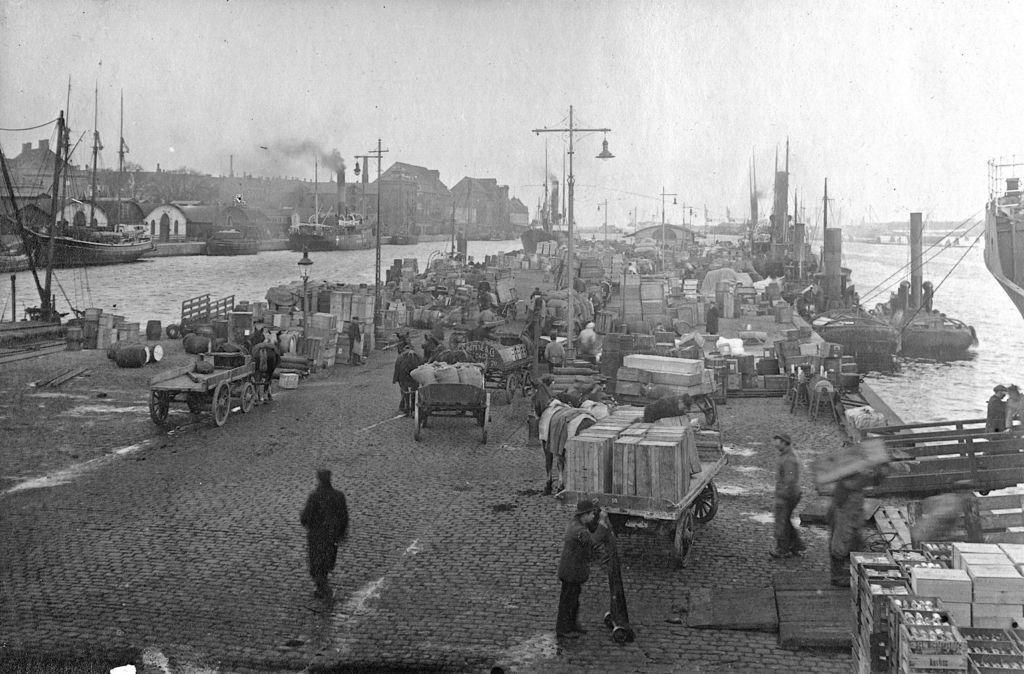What is the color scheme of the image? The image is black and white. What type of vehicles can be seen in the image? There are carts in the image. What animals are present in the image? There are horses in the image. What structures can be seen in the image? There are poles and houses in the image. What objects are visible in the image? There are boxes in the image. Who or what is present in the image? There are persons in the image. What natural element is visible in the image? There is water visible in the image. What can be seen in the background of the image? There are houses, smoke, and the sky visible in the background of the image. How many fish can be seen swimming in the water in the image? There are no fish visible in the image; it only shows water. What type of fairies are flying around the horses in the image? There are no fairies present in the image; it only features horses, carts, and other objects. 